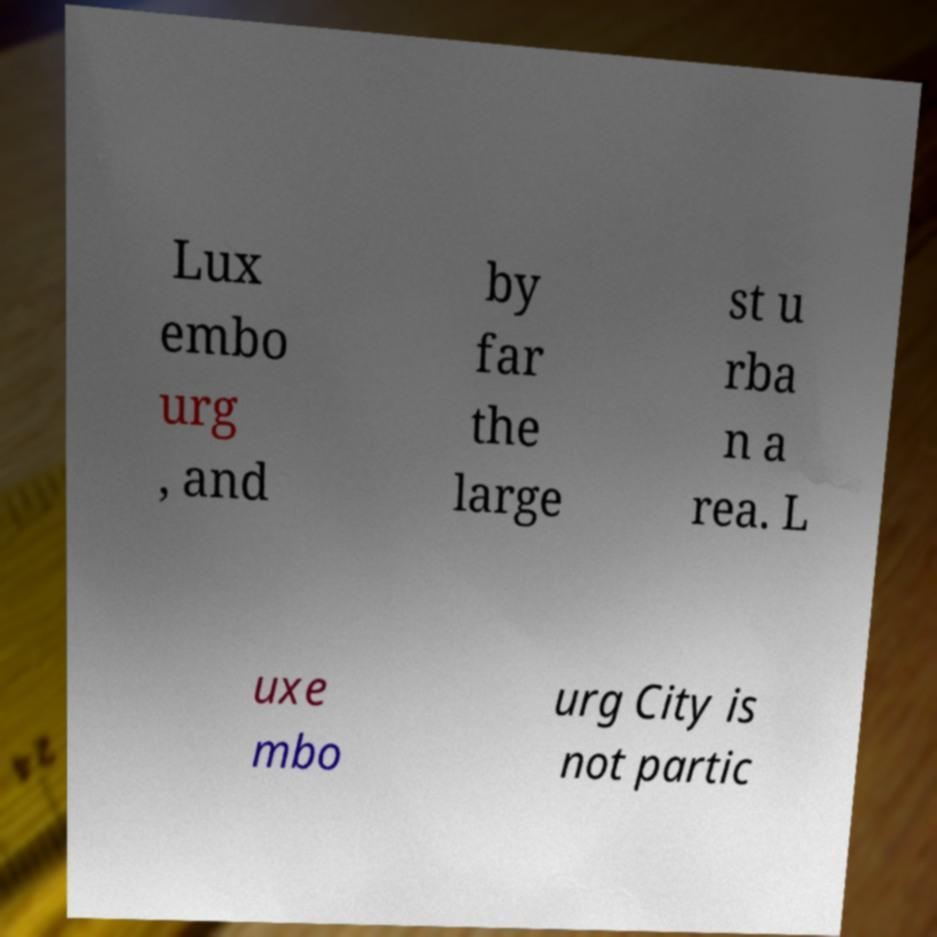What messages or text are displayed in this image? I need them in a readable, typed format. Lux embo urg , and by far the large st u rba n a rea. L uxe mbo urg City is not partic 